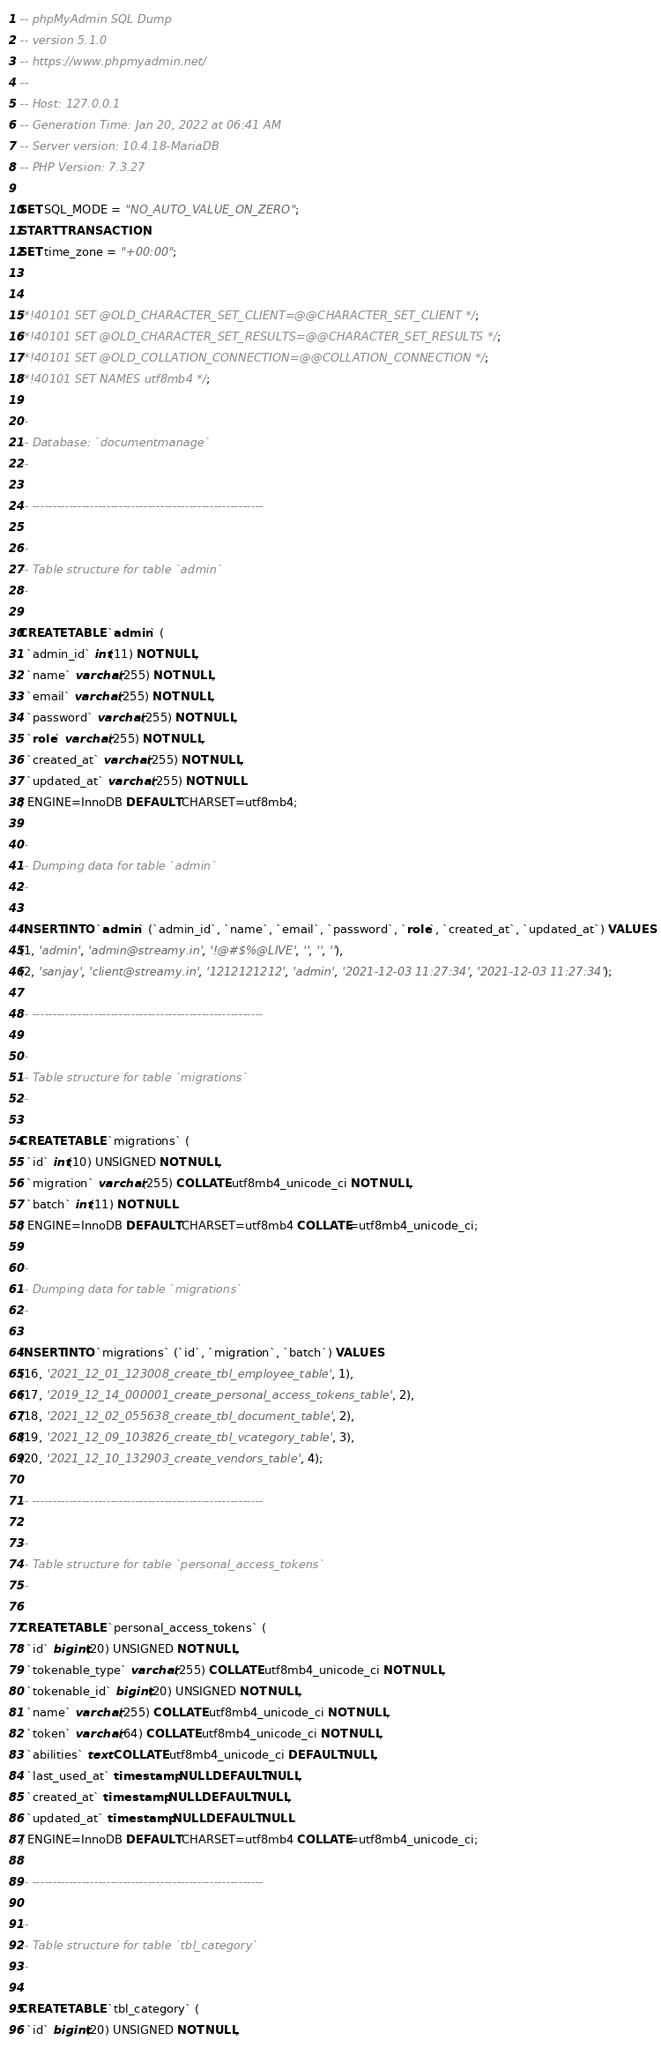Convert code to text. <code><loc_0><loc_0><loc_500><loc_500><_SQL_>-- phpMyAdmin SQL Dump
-- version 5.1.0
-- https://www.phpmyadmin.net/
--
-- Host: 127.0.0.1
-- Generation Time: Jan 20, 2022 at 06:41 AM
-- Server version: 10.4.18-MariaDB
-- PHP Version: 7.3.27

SET SQL_MODE = "NO_AUTO_VALUE_ON_ZERO";
START TRANSACTION;
SET time_zone = "+00:00";


/*!40101 SET @OLD_CHARACTER_SET_CLIENT=@@CHARACTER_SET_CLIENT */;
/*!40101 SET @OLD_CHARACTER_SET_RESULTS=@@CHARACTER_SET_RESULTS */;
/*!40101 SET @OLD_COLLATION_CONNECTION=@@COLLATION_CONNECTION */;
/*!40101 SET NAMES utf8mb4 */;

--
-- Database: `documentmanage`
--

-- --------------------------------------------------------

--
-- Table structure for table `admin`
--

CREATE TABLE `admin` (
  `admin_id` int(11) NOT NULL,
  `name` varchar(255) NOT NULL,
  `email` varchar(255) NOT NULL,
  `password` varchar(255) NOT NULL,
  `role` varchar(255) NOT NULL,
  `created_at` varchar(255) NOT NULL,
  `updated_at` varchar(255) NOT NULL
) ENGINE=InnoDB DEFAULT CHARSET=utf8mb4;

--
-- Dumping data for table `admin`
--

INSERT INTO `admin` (`admin_id`, `name`, `email`, `password`, `role`, `created_at`, `updated_at`) VALUES
(1, 'admin', 'admin@streamy.in', '!@#$%@LIVE', '', '', ''),
(2, 'sanjay', 'client@streamy.in', '1212121212', 'admin', '2021-12-03 11:27:34', '2021-12-03 11:27:34');

-- --------------------------------------------------------

--
-- Table structure for table `migrations`
--

CREATE TABLE `migrations` (
  `id` int(10) UNSIGNED NOT NULL,
  `migration` varchar(255) COLLATE utf8mb4_unicode_ci NOT NULL,
  `batch` int(11) NOT NULL
) ENGINE=InnoDB DEFAULT CHARSET=utf8mb4 COLLATE=utf8mb4_unicode_ci;

--
-- Dumping data for table `migrations`
--

INSERT INTO `migrations` (`id`, `migration`, `batch`) VALUES
(16, '2021_12_01_123008_create_tbl_employee_table', 1),
(17, '2019_12_14_000001_create_personal_access_tokens_table', 2),
(18, '2021_12_02_055638_create_tbl_document_table', 2),
(19, '2021_12_09_103826_create_tbl_vcategory_table', 3),
(20, '2021_12_10_132903_create_vendors_table', 4);

-- --------------------------------------------------------

--
-- Table structure for table `personal_access_tokens`
--

CREATE TABLE `personal_access_tokens` (
  `id` bigint(20) UNSIGNED NOT NULL,
  `tokenable_type` varchar(255) COLLATE utf8mb4_unicode_ci NOT NULL,
  `tokenable_id` bigint(20) UNSIGNED NOT NULL,
  `name` varchar(255) COLLATE utf8mb4_unicode_ci NOT NULL,
  `token` varchar(64) COLLATE utf8mb4_unicode_ci NOT NULL,
  `abilities` text COLLATE utf8mb4_unicode_ci DEFAULT NULL,
  `last_used_at` timestamp NULL DEFAULT NULL,
  `created_at` timestamp NULL DEFAULT NULL,
  `updated_at` timestamp NULL DEFAULT NULL
) ENGINE=InnoDB DEFAULT CHARSET=utf8mb4 COLLATE=utf8mb4_unicode_ci;

-- --------------------------------------------------------

--
-- Table structure for table `tbl_category`
--

CREATE TABLE `tbl_category` (
  `id` bigint(20) UNSIGNED NOT NULL,</code> 